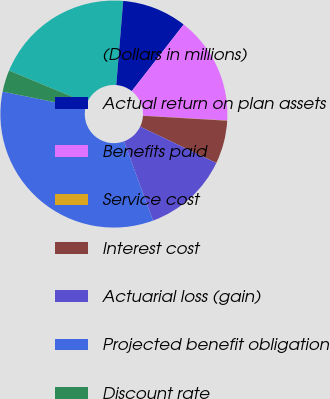Convert chart to OTSL. <chart><loc_0><loc_0><loc_500><loc_500><pie_chart><fcel>(Dollars in millions)<fcel>Actual return on plan assets<fcel>Benefits paid<fcel>Service cost<fcel>Interest cost<fcel>Actuarial loss (gain)<fcel>Projected benefit obligation<fcel>Discount rate<nl><fcel>20.05%<fcel>9.23%<fcel>15.37%<fcel>0.03%<fcel>6.16%<fcel>12.3%<fcel>33.77%<fcel>3.1%<nl></chart> 